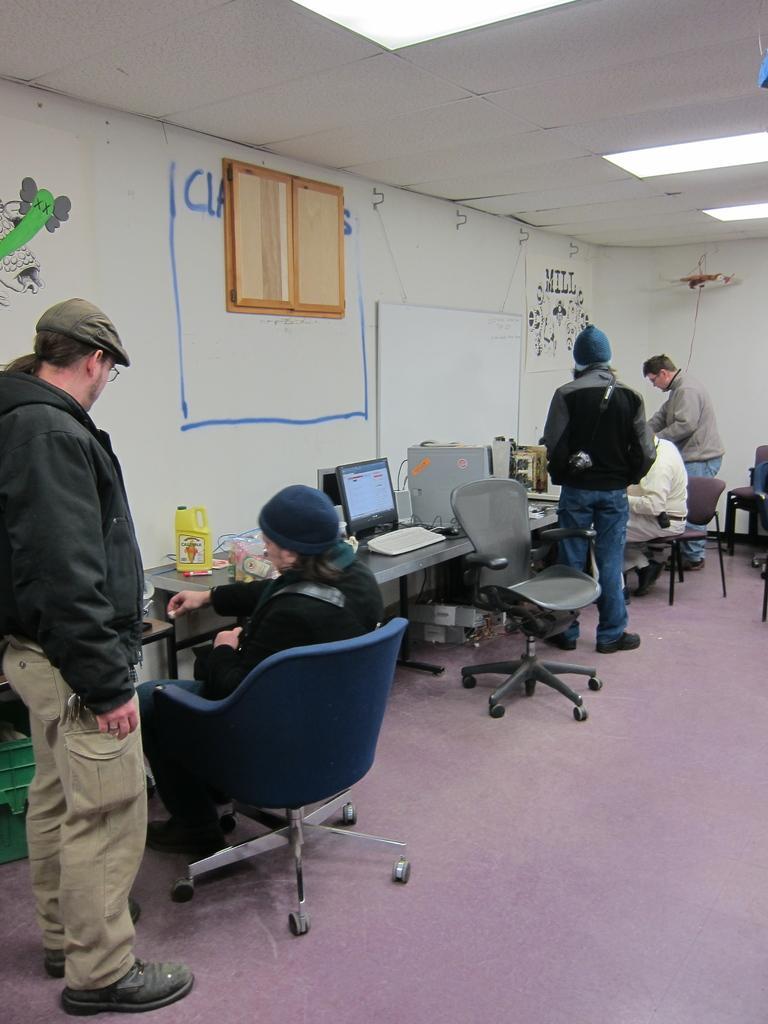Please provide a concise description of this image. Here we can see a couple of people sitting on chairs and a group of people standing beside them having tables in front of them with laptops and some other accessories present on it, we can see a board on the wall, we can see lights present 